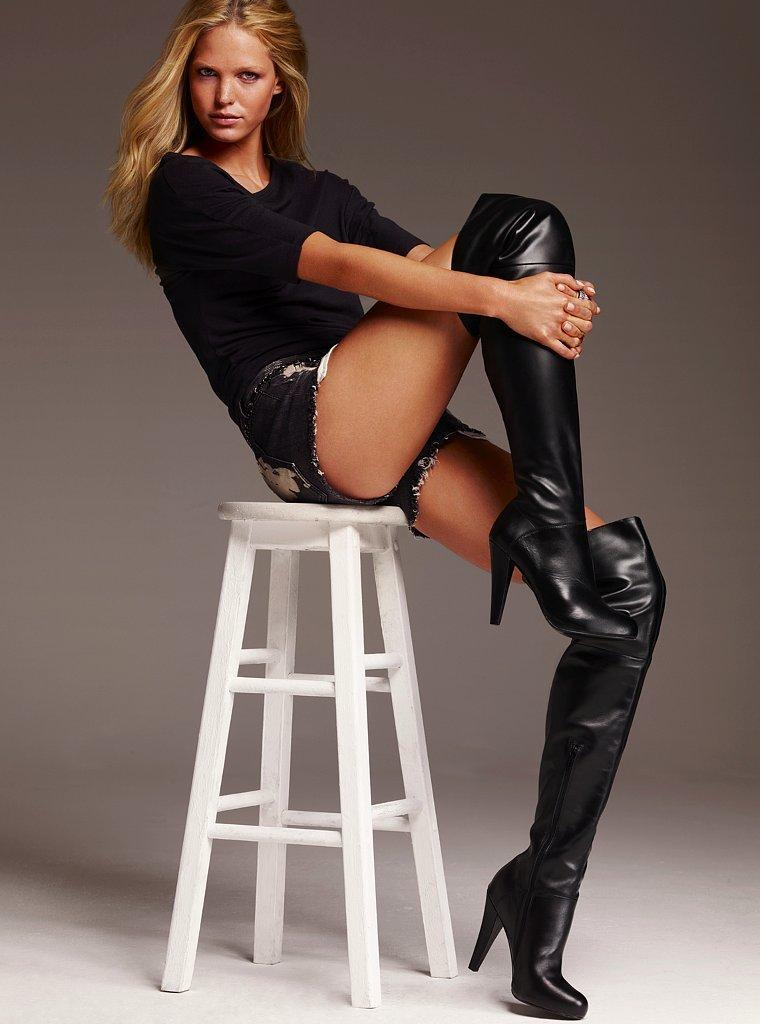Who is the main subject in the image? There is a woman in the image. What is the woman wearing? The woman is wearing a black dress and black boots. What is the woman sitting on in the image? The woman is sitting on a white stool. What is the color of the floor in the image? The floor in the image is white. How many hands does the woman have in the image? The image does not show the woman's hands, so it is impossible to determine the number of hands she has. 